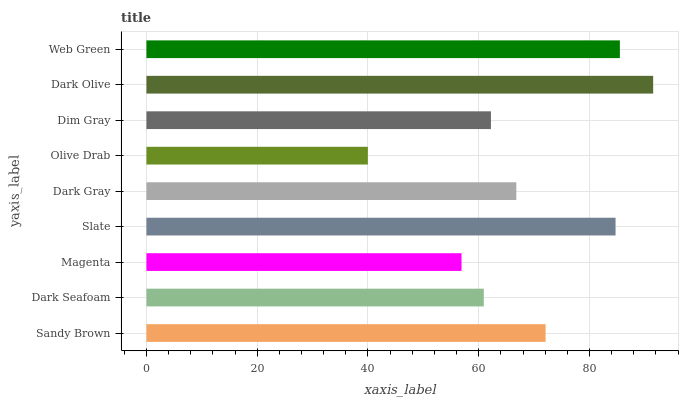Is Olive Drab the minimum?
Answer yes or no. Yes. Is Dark Olive the maximum?
Answer yes or no. Yes. Is Dark Seafoam the minimum?
Answer yes or no. No. Is Dark Seafoam the maximum?
Answer yes or no. No. Is Sandy Brown greater than Dark Seafoam?
Answer yes or no. Yes. Is Dark Seafoam less than Sandy Brown?
Answer yes or no. Yes. Is Dark Seafoam greater than Sandy Brown?
Answer yes or no. No. Is Sandy Brown less than Dark Seafoam?
Answer yes or no. No. Is Dark Gray the high median?
Answer yes or no. Yes. Is Dark Gray the low median?
Answer yes or no. Yes. Is Olive Drab the high median?
Answer yes or no. No. Is Sandy Brown the low median?
Answer yes or no. No. 